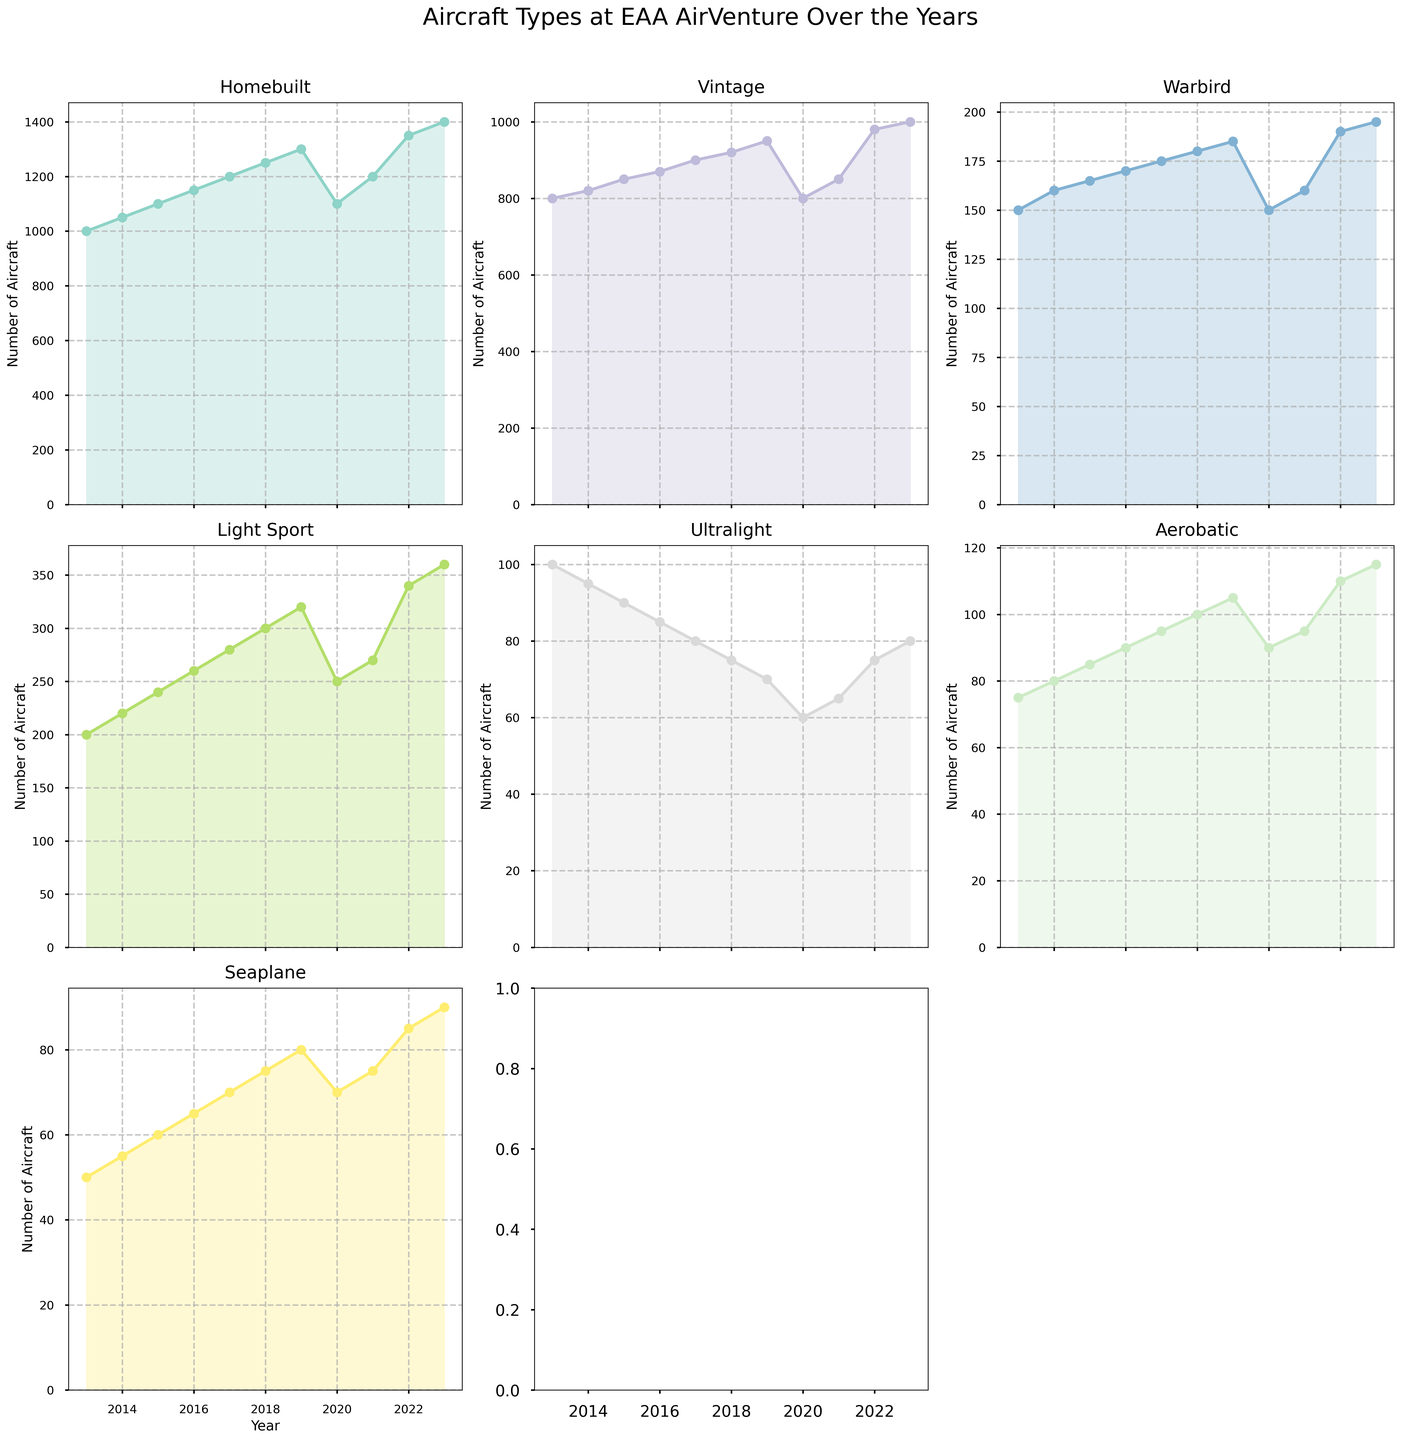What year had the highest number for the Homebuilt category? Find the plot for the Homebuilt category, then identify the highest point on the plot and trace it to the corresponding year.
Answer: 2023 In which year was the number of Vintage aircraft equal to the number of Warbird aircraft? Check the plots for both Vintage and Warbird aircraft, and look for the point where the two plots intersect.
Answer: Never intersect In 2023, compare the number of Warbird and Ultralight aircraft. Which category had more aircraft? Find the values for Warbird and Ultralight in the year 2023 and compare them.
Answer: Warbird By how much did the number of Aerobatic aircraft increase from 2013 to 2023? Locate the Aerobatic plot, identify the values for 2013 and 2023, and subtract the 2013 value from the 2023 value.
Answer: 40 What is the trend for the Seaplane category over the years shown in the figure? Look at the plot for the Seaplane category and observe whether it generally inclines, declines, or remains stable over the years.
Answer: Increasing Which category had the sharpest decline in the year 2020 compared to 2019? Compare all the categories between 2019 and 2020 plots and identify which has the steepest drop.
Answer: Homebuilt What is the average number of Light Sport aircraft from 2013 to 2023? Add up all the values for Light Sport from 2013 to 2023 and divide by the number of years (11).
Answer: 271 Was there any year where the number of Homebuilt aircraft was less than Vintage aircraft? Look at the Homebuilt and Vintage plots and check if there is any point where Homebuilt has a lower value than Vintage.
Answer: No In which year did Ultralight aircraft see the lowest number represented in the figure? Find the lowest point on the Ultralight plot and trace it to the corresponding year.
Answer: 2020 Compare the number of Aerobatic aircraft in 2013 with 2023 and calculate the percentage increase. Subtract the 2013 value from the 2023 value, divide by the 2013 value, and multiply by 100 to get the percentage.
Answer: 53.33% 